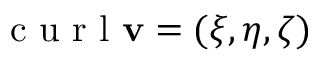Convert formula to latex. <formula><loc_0><loc_0><loc_500><loc_500>c u r l v = ( \xi , \eta , \zeta )</formula> 